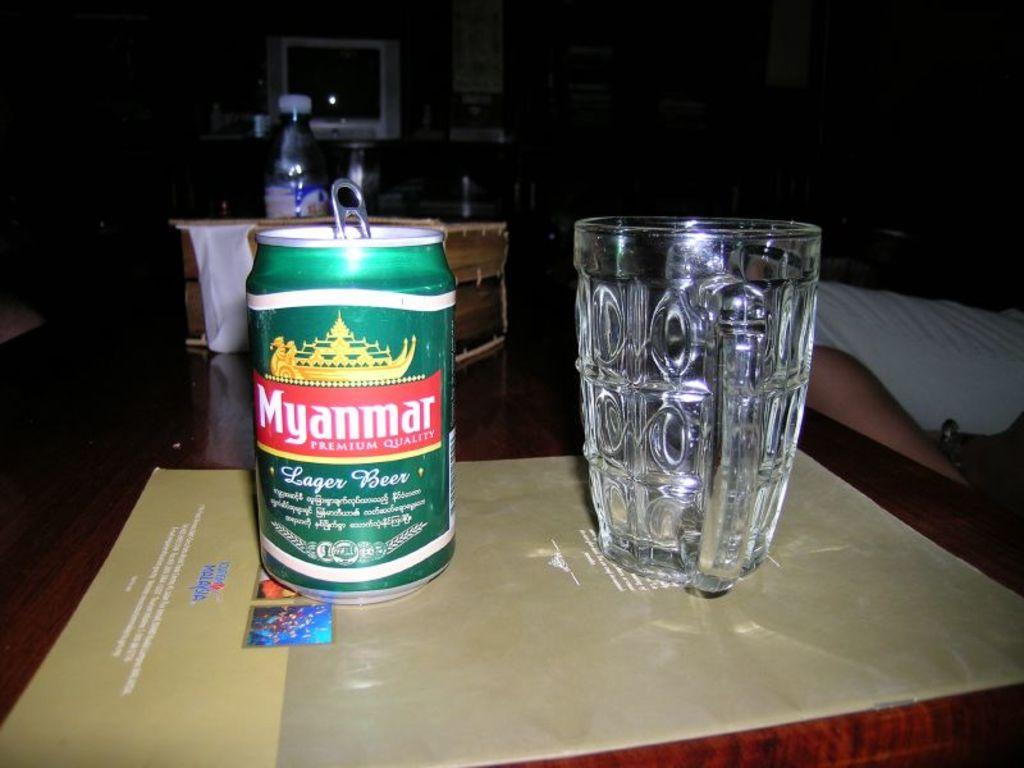Provide a one-sentence caption for the provided image. An empty glass is sitting to the right of a can of Myanmar Lager Beer. 